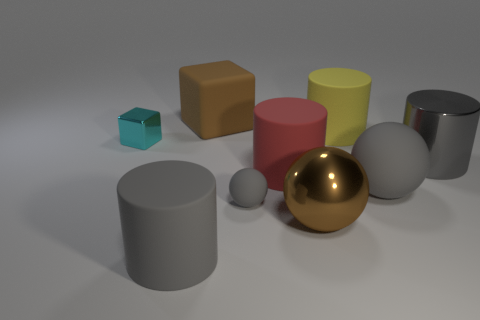Subtract all blue balls. How many gray cylinders are left? 2 Subtract all big matte cylinders. How many cylinders are left? 1 Subtract all red cylinders. How many cylinders are left? 3 Subtract all green cylinders. Subtract all green blocks. How many cylinders are left? 4 Add 1 large yellow cylinders. How many objects exist? 10 Subtract all blocks. How many objects are left? 7 Subtract 1 gray cylinders. How many objects are left? 8 Subtract all brown cubes. Subtract all big matte cylinders. How many objects are left? 5 Add 4 big brown things. How many big brown things are left? 6 Add 8 big purple balls. How many big purple balls exist? 8 